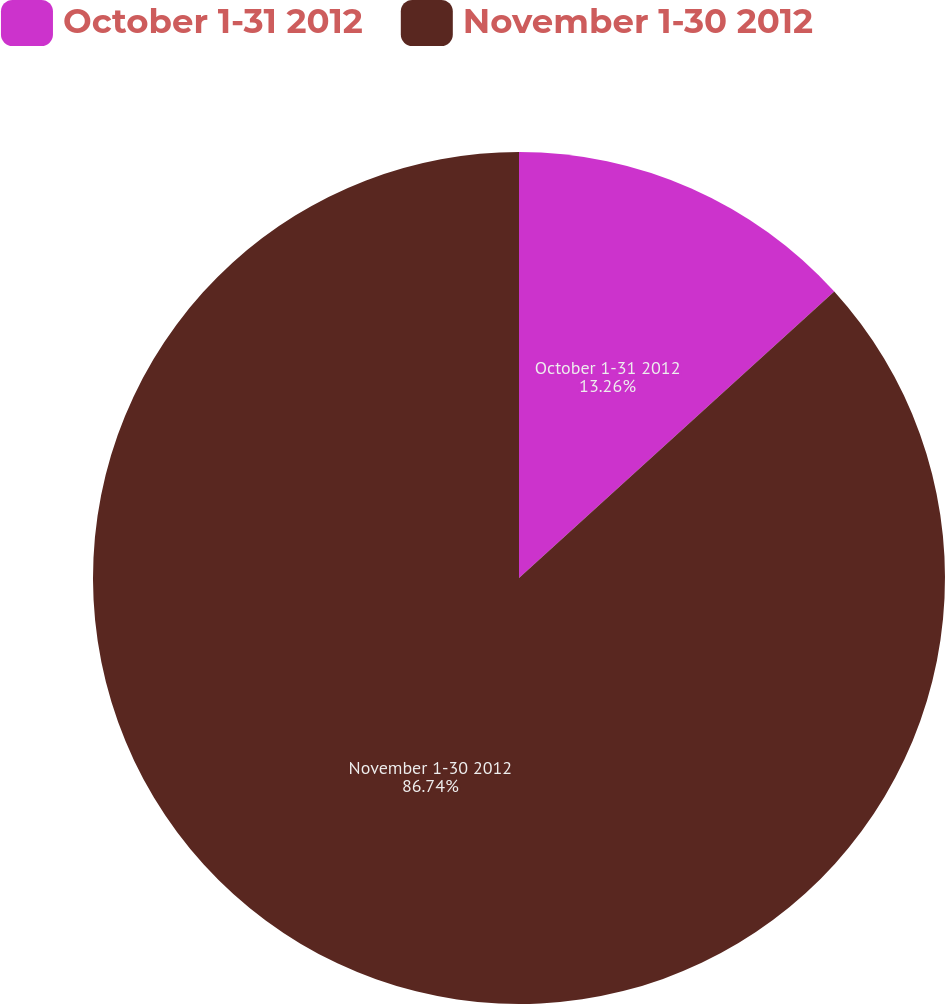<chart> <loc_0><loc_0><loc_500><loc_500><pie_chart><fcel>October 1-31 2012<fcel>November 1-30 2012<nl><fcel>13.26%<fcel>86.74%<nl></chart> 